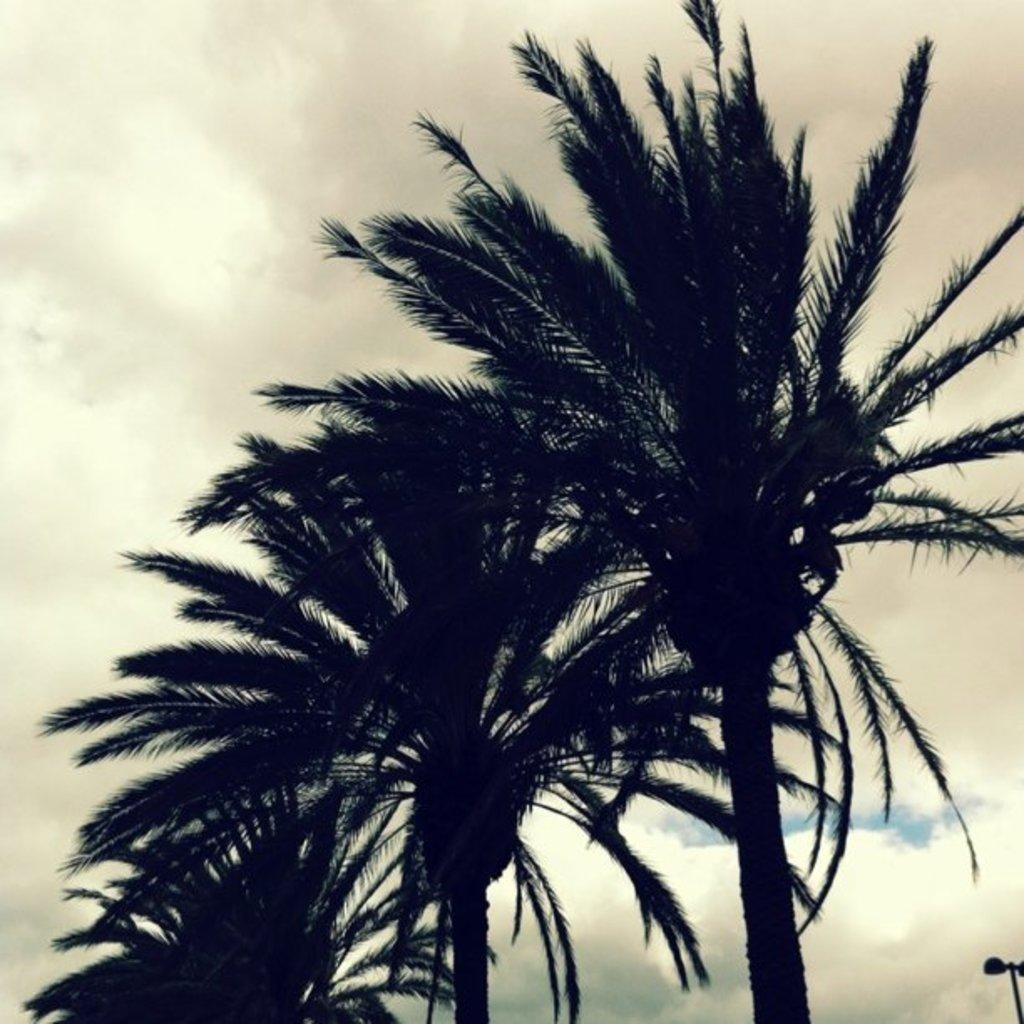What type of natural elements can be seen in the image? There are trees in the image. Where is the street light located in the image? The street light is in the right bottom of the image. What can be seen in the background of the image? The sky is visible in the background of the image, and clouds are present. What type of stocking is hanging from the tree in the image? There is no stocking hanging from the tree in the image. What ornament is placed on top of the street light in the image? There is no ornament present on top of the street light in the image. 